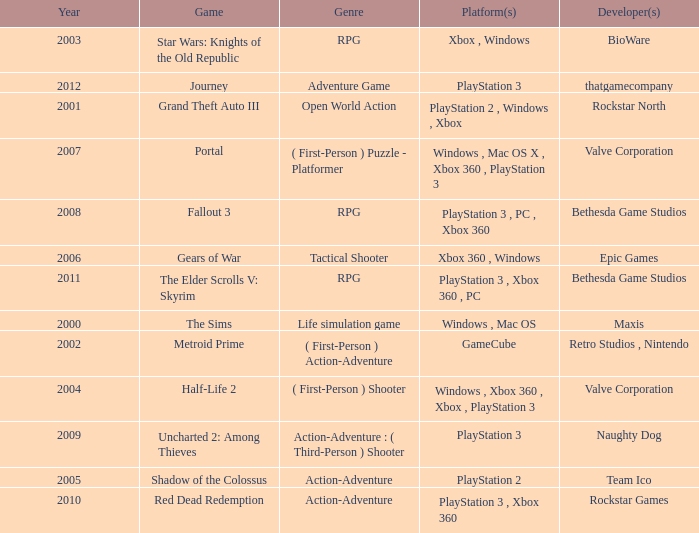What game was in 2001? Grand Theft Auto III. 